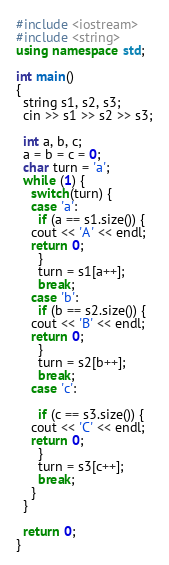<code> <loc_0><loc_0><loc_500><loc_500><_C++_>#include <iostream>
#include <string>
using namespace std;

int main()
{
  string s1, s2, s3;
  cin >> s1 >> s2 >> s3;

  int a, b, c;
  a = b = c = 0;
  char turn = 'a';
  while (1) {
    switch(turn) {
    case 'a':
      if (a == s1.size()) {
	cout << 'A' << endl;
	return 0;
      }
      turn = s1[a++];
      break;
    case 'b':
      if (b == s2.size()) {
	cout << 'B' << endl;
	return 0;
      }
      turn = s2[b++];
      break;
    case 'c':
      
      if (c == s3.size()) {
	cout << 'C' << endl;
	return 0;
      }
      turn = s3[c++];
      break;
    }
  }
  
  return 0;
}
</code> 